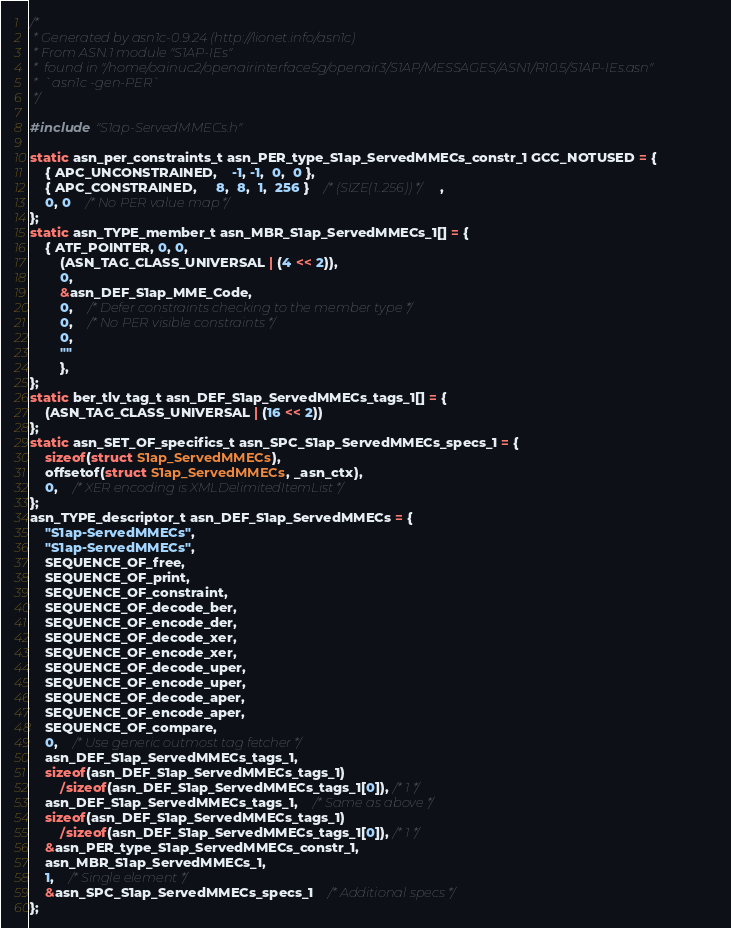Convert code to text. <code><loc_0><loc_0><loc_500><loc_500><_C_>/*
 * Generated by asn1c-0.9.24 (http://lionet.info/asn1c)
 * From ASN.1 module "S1AP-IEs"
 * 	found in "/home/oainuc2/openairinterface5g/openair3/S1AP/MESSAGES/ASN1/R10.5/S1AP-IEs.asn"
 * 	`asn1c -gen-PER`
 */

#include "S1ap-ServedMMECs.h"

static asn_per_constraints_t asn_PER_type_S1ap_ServedMMECs_constr_1 GCC_NOTUSED = {
	{ APC_UNCONSTRAINED,	-1, -1,  0,  0 },
	{ APC_CONSTRAINED,	 8,  8,  1,  256 }	/* (SIZE(1..256)) */,
	0, 0	/* No PER value map */
};
static asn_TYPE_member_t asn_MBR_S1ap_ServedMMECs_1[] = {
	{ ATF_POINTER, 0, 0,
		(ASN_TAG_CLASS_UNIVERSAL | (4 << 2)),
		0,
		&asn_DEF_S1ap_MME_Code,
		0,	/* Defer constraints checking to the member type */
		0,	/* No PER visible constraints */
		0,
		""
		},
};
static ber_tlv_tag_t asn_DEF_S1ap_ServedMMECs_tags_1[] = {
	(ASN_TAG_CLASS_UNIVERSAL | (16 << 2))
};
static asn_SET_OF_specifics_t asn_SPC_S1ap_ServedMMECs_specs_1 = {
	sizeof(struct S1ap_ServedMMECs),
	offsetof(struct S1ap_ServedMMECs, _asn_ctx),
	0,	/* XER encoding is XMLDelimitedItemList */
};
asn_TYPE_descriptor_t asn_DEF_S1ap_ServedMMECs = {
	"S1ap-ServedMMECs",
	"S1ap-ServedMMECs",
	SEQUENCE_OF_free,
	SEQUENCE_OF_print,
	SEQUENCE_OF_constraint,
	SEQUENCE_OF_decode_ber,
	SEQUENCE_OF_encode_der,
	SEQUENCE_OF_decode_xer,
	SEQUENCE_OF_encode_xer,
	SEQUENCE_OF_decode_uper,
	SEQUENCE_OF_encode_uper,
	SEQUENCE_OF_decode_aper,
	SEQUENCE_OF_encode_aper,
	SEQUENCE_OF_compare,
	0,	/* Use generic outmost tag fetcher */
	asn_DEF_S1ap_ServedMMECs_tags_1,
	sizeof(asn_DEF_S1ap_ServedMMECs_tags_1)
		/sizeof(asn_DEF_S1ap_ServedMMECs_tags_1[0]), /* 1 */
	asn_DEF_S1ap_ServedMMECs_tags_1,	/* Same as above */
	sizeof(asn_DEF_S1ap_ServedMMECs_tags_1)
		/sizeof(asn_DEF_S1ap_ServedMMECs_tags_1[0]), /* 1 */
	&asn_PER_type_S1ap_ServedMMECs_constr_1,
	asn_MBR_S1ap_ServedMMECs_1,
	1,	/* Single element */
	&asn_SPC_S1ap_ServedMMECs_specs_1	/* Additional specs */
};

</code> 